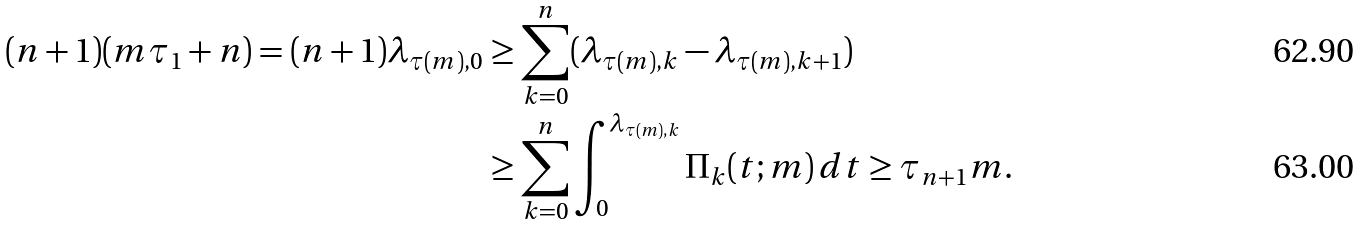Convert formula to latex. <formula><loc_0><loc_0><loc_500><loc_500>( n + 1 ) ( m \tau _ { 1 } + n ) = ( n + 1 ) \lambda _ { \tau ( m ) , 0 } & \geq \sum _ { k = 0 } ^ { n } ( \lambda _ { \tau ( m ) , k } - \lambda _ { \tau ( m ) , k + 1 } ) \\ & \geq \sum _ { k = 0 } ^ { n } \int _ { 0 } ^ { \lambda _ { \tau ( m ) , k } } \Pi _ { k } ( t ; m ) \, d t \geq \tau _ { n + 1 } m .</formula> 